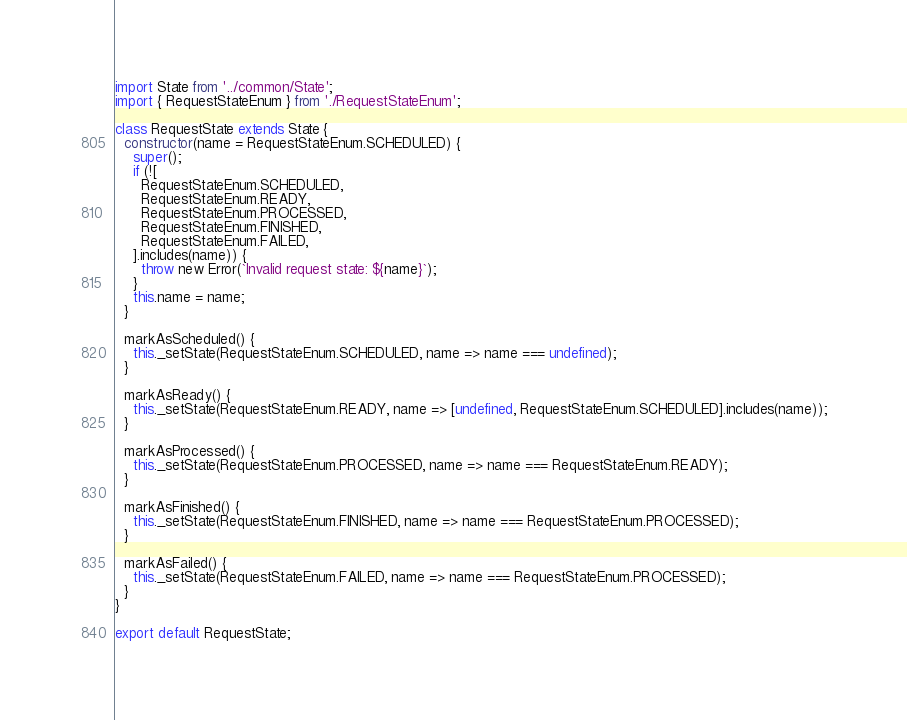Convert code to text. <code><loc_0><loc_0><loc_500><loc_500><_TypeScript_>import State from '../common/State';
import { RequestStateEnum } from './RequestStateEnum';

class RequestState extends State {
  constructor(name = RequestStateEnum.SCHEDULED) {
    super();
    if (![
      RequestStateEnum.SCHEDULED,
      RequestStateEnum.READY,
      RequestStateEnum.PROCESSED,
      RequestStateEnum.FINISHED,
      RequestStateEnum.FAILED,
    ].includes(name)) {
      throw new Error(`Invalid request state: ${name}`);
    }
    this.name = name;
  }

  markAsScheduled() {
    this._setState(RequestStateEnum.SCHEDULED, name => name === undefined);
  }

  markAsReady() {
    this._setState(RequestStateEnum.READY, name => [undefined, RequestStateEnum.SCHEDULED].includes(name));
  }

  markAsProcessed() {
    this._setState(RequestStateEnum.PROCESSED, name => name === RequestStateEnum.READY);
  }

  markAsFinished() {
    this._setState(RequestStateEnum.FINISHED, name => name === RequestStateEnum.PROCESSED);
  }

  markAsFailed() {
    this._setState(RequestStateEnum.FAILED, name => name === RequestStateEnum.PROCESSED);
  }
}

export default RequestState;
</code> 